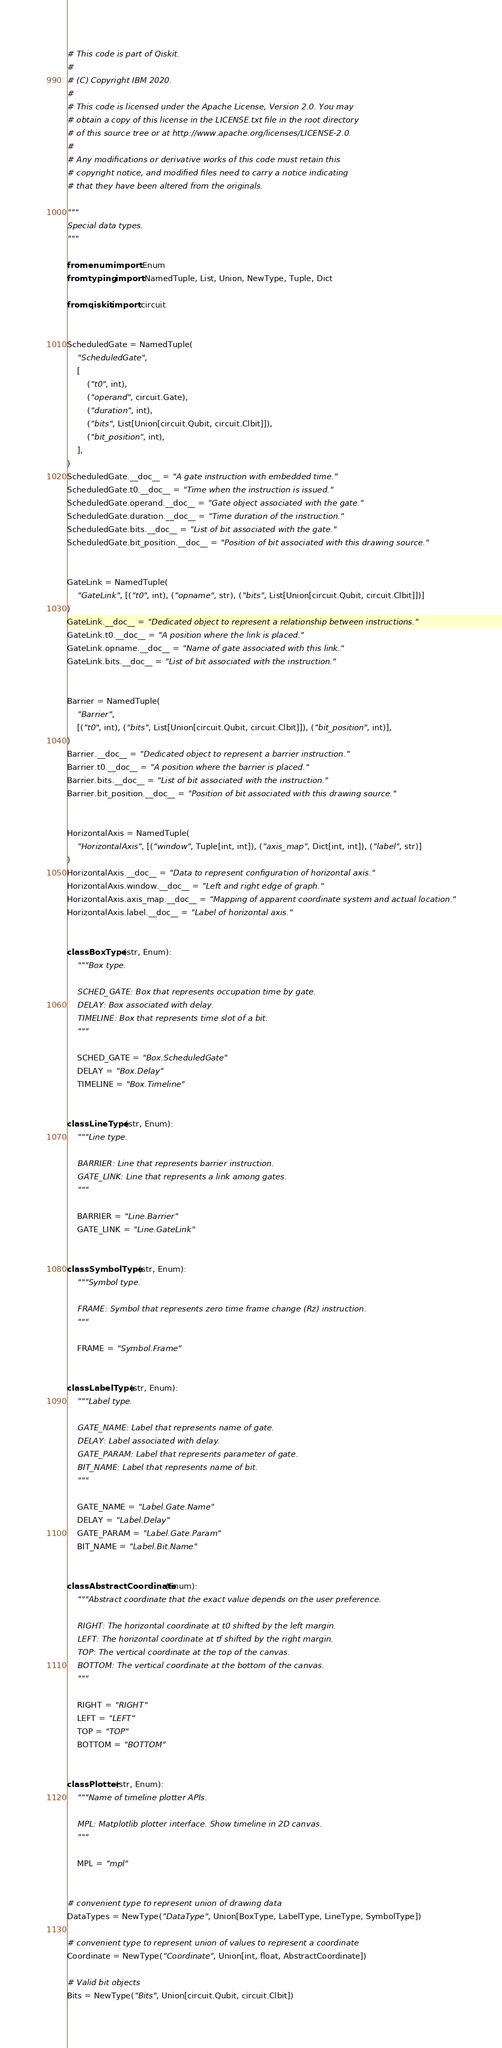Convert code to text. <code><loc_0><loc_0><loc_500><loc_500><_Python_># This code is part of Qiskit.
#
# (C) Copyright IBM 2020.
#
# This code is licensed under the Apache License, Version 2.0. You may
# obtain a copy of this license in the LICENSE.txt file in the root directory
# of this source tree or at http://www.apache.org/licenses/LICENSE-2.0.
#
# Any modifications or derivative works of this code must retain this
# copyright notice, and modified files need to carry a notice indicating
# that they have been altered from the originals.

"""
Special data types.
"""

from enum import Enum
from typing import NamedTuple, List, Union, NewType, Tuple, Dict

from qiskit import circuit


ScheduledGate = NamedTuple(
    "ScheduledGate",
    [
        ("t0", int),
        ("operand", circuit.Gate),
        ("duration", int),
        ("bits", List[Union[circuit.Qubit, circuit.Clbit]]),
        ("bit_position", int),
    ],
)
ScheduledGate.__doc__ = "A gate instruction with embedded time."
ScheduledGate.t0.__doc__ = "Time when the instruction is issued."
ScheduledGate.operand.__doc__ = "Gate object associated with the gate."
ScheduledGate.duration.__doc__ = "Time duration of the instruction."
ScheduledGate.bits.__doc__ = "List of bit associated with the gate."
ScheduledGate.bit_position.__doc__ = "Position of bit associated with this drawing source."


GateLink = NamedTuple(
    "GateLink", [("t0", int), ("opname", str), ("bits", List[Union[circuit.Qubit, circuit.Clbit]])]
)
GateLink.__doc__ = "Dedicated object to represent a relationship between instructions."
GateLink.t0.__doc__ = "A position where the link is placed."
GateLink.opname.__doc__ = "Name of gate associated with this link."
GateLink.bits.__doc__ = "List of bit associated with the instruction."


Barrier = NamedTuple(
    "Barrier",
    [("t0", int), ("bits", List[Union[circuit.Qubit, circuit.Clbit]]), ("bit_position", int)],
)
Barrier.__doc__ = "Dedicated object to represent a barrier instruction."
Barrier.t0.__doc__ = "A position where the barrier is placed."
Barrier.bits.__doc__ = "List of bit associated with the instruction."
Barrier.bit_position.__doc__ = "Position of bit associated with this drawing source."


HorizontalAxis = NamedTuple(
    "HorizontalAxis", [("window", Tuple[int, int]), ("axis_map", Dict[int, int]), ("label", str)]
)
HorizontalAxis.__doc__ = "Data to represent configuration of horizontal axis."
HorizontalAxis.window.__doc__ = "Left and right edge of graph."
HorizontalAxis.axis_map.__doc__ = "Mapping of apparent coordinate system and actual location."
HorizontalAxis.label.__doc__ = "Label of horizontal axis."


class BoxType(str, Enum):
    """Box type.

    SCHED_GATE: Box that represents occupation time by gate.
    DELAY: Box associated with delay.
    TIMELINE: Box that represents time slot of a bit.
    """

    SCHED_GATE = "Box.ScheduledGate"
    DELAY = "Box.Delay"
    TIMELINE = "Box.Timeline"


class LineType(str, Enum):
    """Line type.

    BARRIER: Line that represents barrier instruction.
    GATE_LINK: Line that represents a link among gates.
    """

    BARRIER = "Line.Barrier"
    GATE_LINK = "Line.GateLink"


class SymbolType(str, Enum):
    """Symbol type.

    FRAME: Symbol that represents zero time frame change (Rz) instruction.
    """

    FRAME = "Symbol.Frame"


class LabelType(str, Enum):
    """Label type.

    GATE_NAME: Label that represents name of gate.
    DELAY: Label associated with delay.
    GATE_PARAM: Label that represents parameter of gate.
    BIT_NAME: Label that represents name of bit.
    """

    GATE_NAME = "Label.Gate.Name"
    DELAY = "Label.Delay"
    GATE_PARAM = "Label.Gate.Param"
    BIT_NAME = "Label.Bit.Name"


class AbstractCoordinate(Enum):
    """Abstract coordinate that the exact value depends on the user preference.

    RIGHT: The horizontal coordinate at t0 shifted by the left margin.
    LEFT: The horizontal coordinate at tf shifted by the right margin.
    TOP: The vertical coordinate at the top of the canvas.
    BOTTOM: The vertical coordinate at the bottom of the canvas.
    """

    RIGHT = "RIGHT"
    LEFT = "LEFT"
    TOP = "TOP"
    BOTTOM = "BOTTOM"


class Plotter(str, Enum):
    """Name of timeline plotter APIs.

    MPL: Matplotlib plotter interface. Show timeline in 2D canvas.
    """

    MPL = "mpl"


# convenient type to represent union of drawing data
DataTypes = NewType("DataType", Union[BoxType, LabelType, LineType, SymbolType])

# convenient type to represent union of values to represent a coordinate
Coordinate = NewType("Coordinate", Union[int, float, AbstractCoordinate])

# Valid bit objects
Bits = NewType("Bits", Union[circuit.Qubit, circuit.Clbit])
</code> 